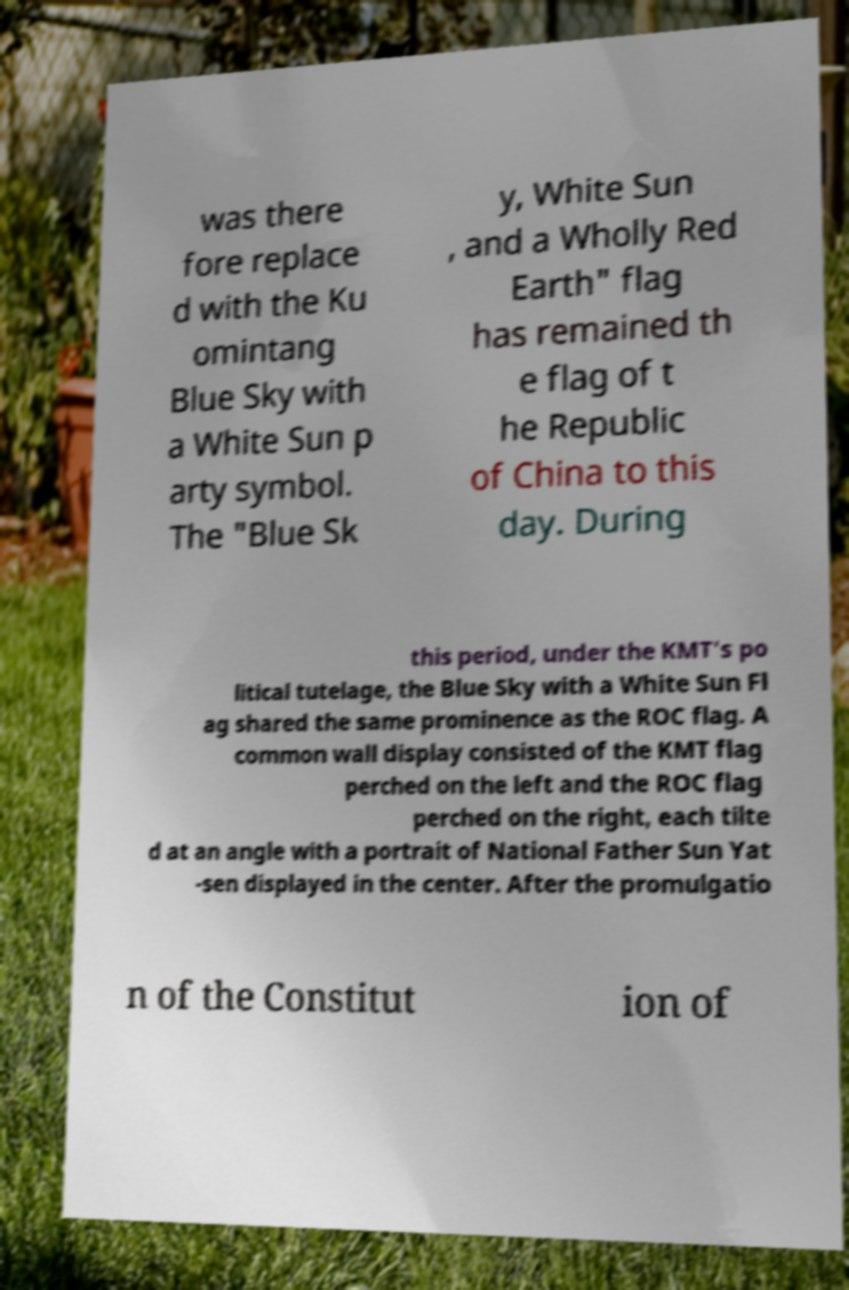What messages or text are displayed in this image? I need them in a readable, typed format. was there fore replace d with the Ku omintang Blue Sky with a White Sun p arty symbol. The "Blue Sk y, White Sun , and a Wholly Red Earth" flag has remained th e flag of t he Republic of China to this day. During this period, under the KMT's po litical tutelage, the Blue Sky with a White Sun Fl ag shared the same prominence as the ROC flag. A common wall display consisted of the KMT flag perched on the left and the ROC flag perched on the right, each tilte d at an angle with a portrait of National Father Sun Yat -sen displayed in the center. After the promulgatio n of the Constitut ion of 